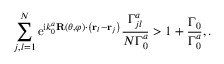<formula> <loc_0><loc_0><loc_500><loc_500>\sum _ { j , l = 1 } ^ { N } e ^ { i k _ { 0 } ^ { a } R ( \theta , \varphi ) \cdot \left ( { r } _ { l } - { r } _ { j } \right ) } \frac { \Gamma _ { j l } ^ { a } } { N \Gamma _ { 0 } ^ { a } } > 1 + \frac { \Gamma _ { 0 } } { \Gamma _ { 0 } ^ { a } } , .</formula> 